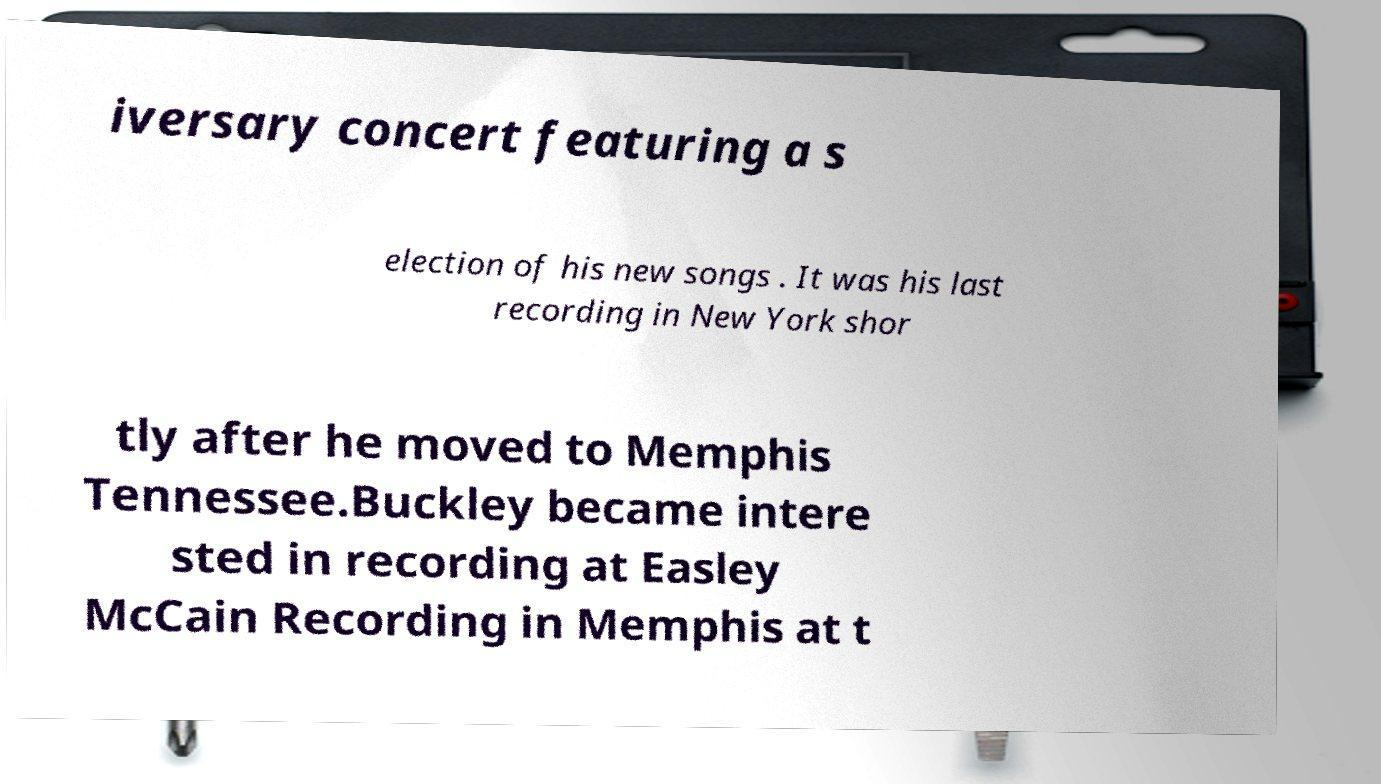Can you accurately transcribe the text from the provided image for me? iversary concert featuring a s election of his new songs . It was his last recording in New York shor tly after he moved to Memphis Tennessee.Buckley became intere sted in recording at Easley McCain Recording in Memphis at t 